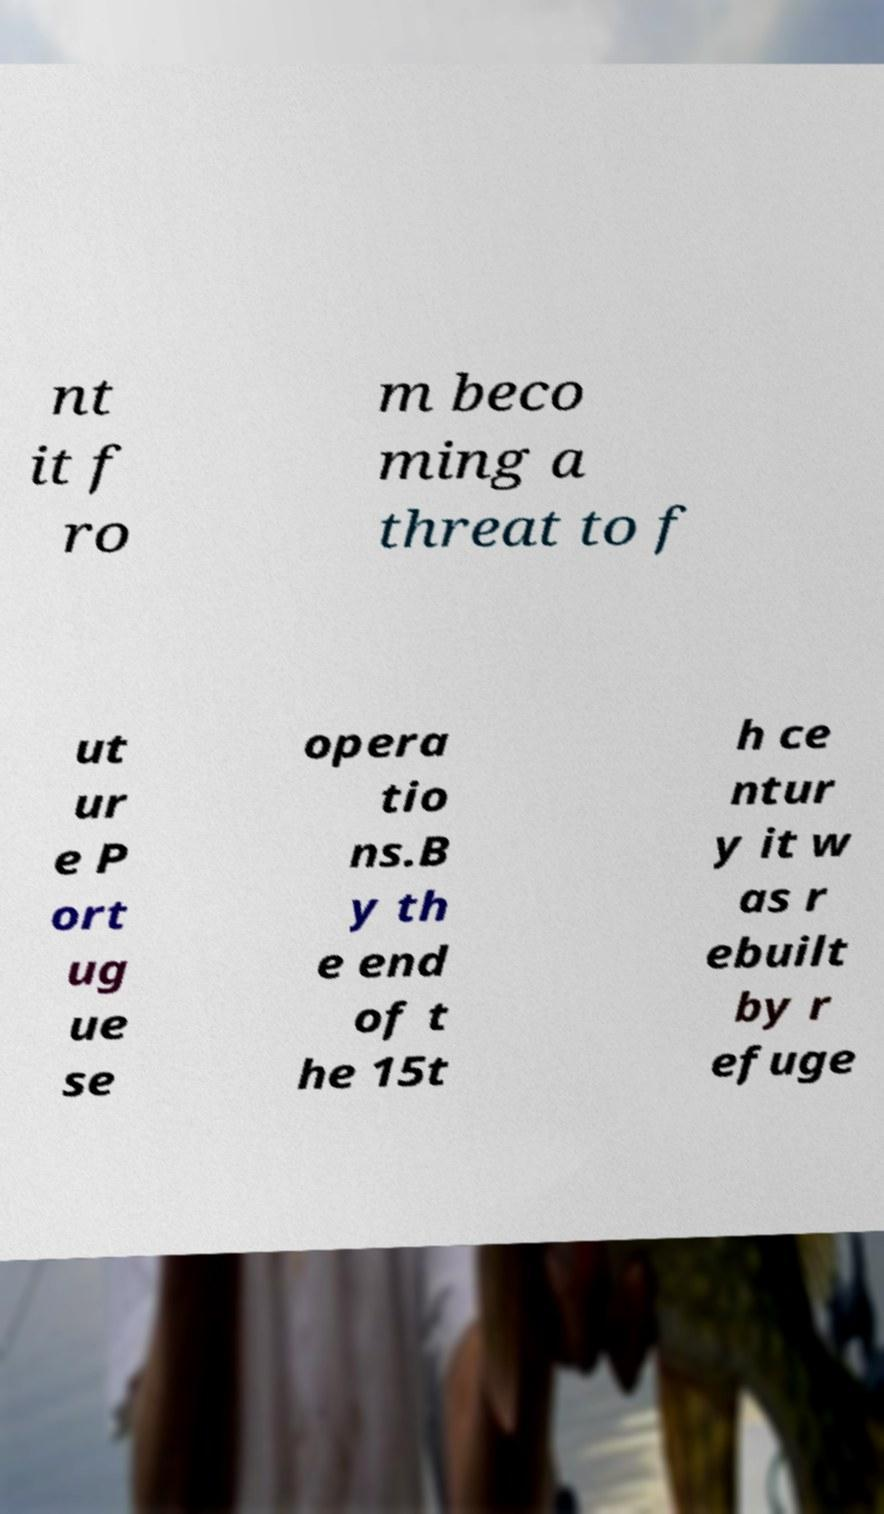I need the written content from this picture converted into text. Can you do that? nt it f ro m beco ming a threat to f ut ur e P ort ug ue se opera tio ns.B y th e end of t he 15t h ce ntur y it w as r ebuilt by r efuge 